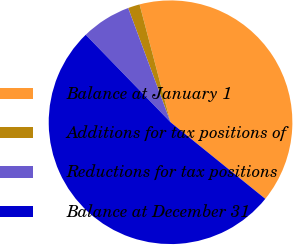<chart> <loc_0><loc_0><loc_500><loc_500><pie_chart><fcel>Balance at January 1<fcel>Additions for tax positions of<fcel>Reductions for tax positions<fcel>Balance at December 31<nl><fcel>39.91%<fcel>1.56%<fcel>6.6%<fcel>51.92%<nl></chart> 